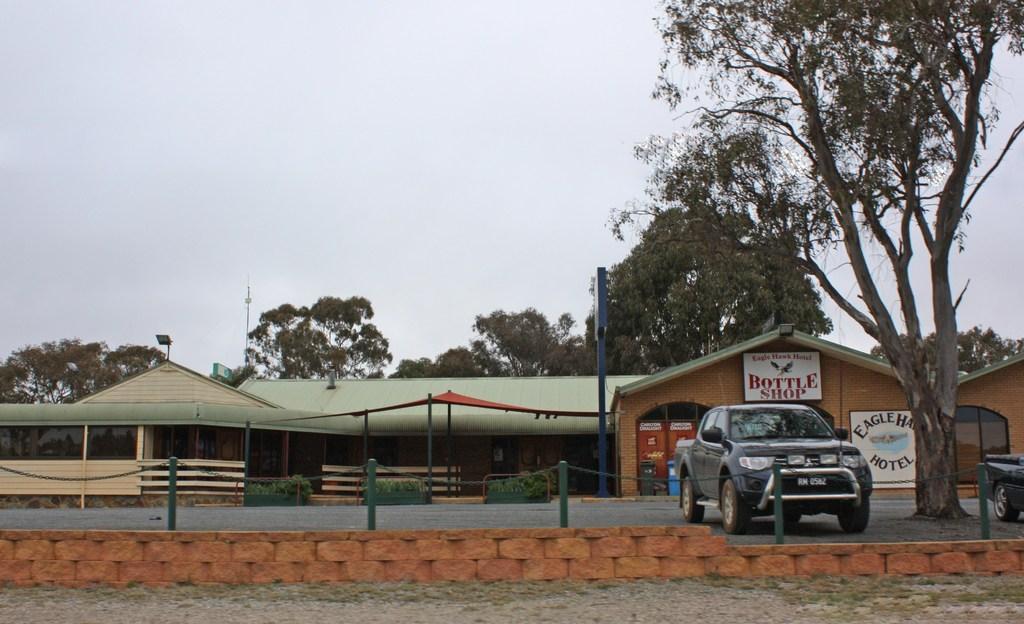Describe this image in one or two sentences. In this image in the center there are poles which are green in colour and there are cars, there is a tree. In the background there are tents and there is a building and on the building there are boards with some text written on it and in the background there are trees and there is a shed which has green colour top. 